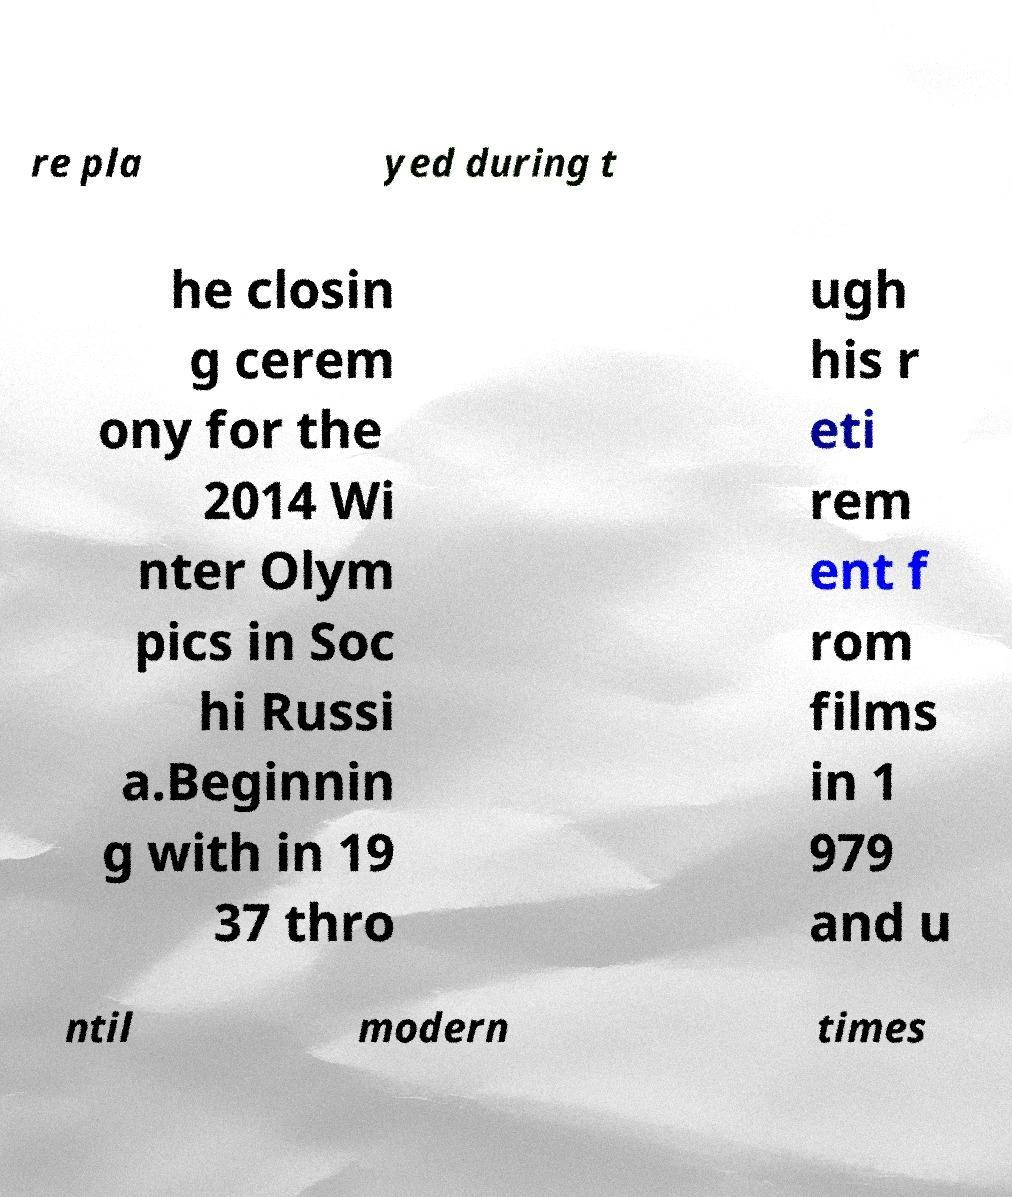Please identify and transcribe the text found in this image. re pla yed during t he closin g cerem ony for the 2014 Wi nter Olym pics in Soc hi Russi a.Beginnin g with in 19 37 thro ugh his r eti rem ent f rom films in 1 979 and u ntil modern times 